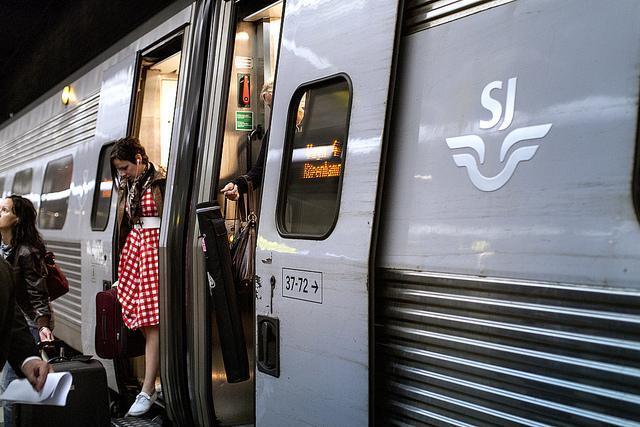How many people are in the photo?
Give a very brief answer. 3. How many suitcases are there?
Give a very brief answer. 3. 